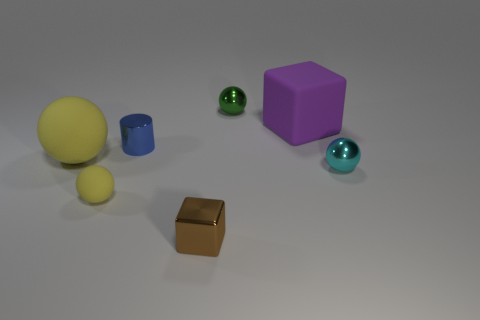Subtract all gray spheres. Subtract all brown cubes. How many spheres are left? 4 Add 3 big yellow matte things. How many objects exist? 10 Subtract all cylinders. How many objects are left? 6 Subtract all blue objects. Subtract all small red blocks. How many objects are left? 6 Add 7 cyan metal spheres. How many cyan metal spheres are left? 8 Add 5 blue metallic cylinders. How many blue metallic cylinders exist? 6 Subtract 0 blue spheres. How many objects are left? 7 